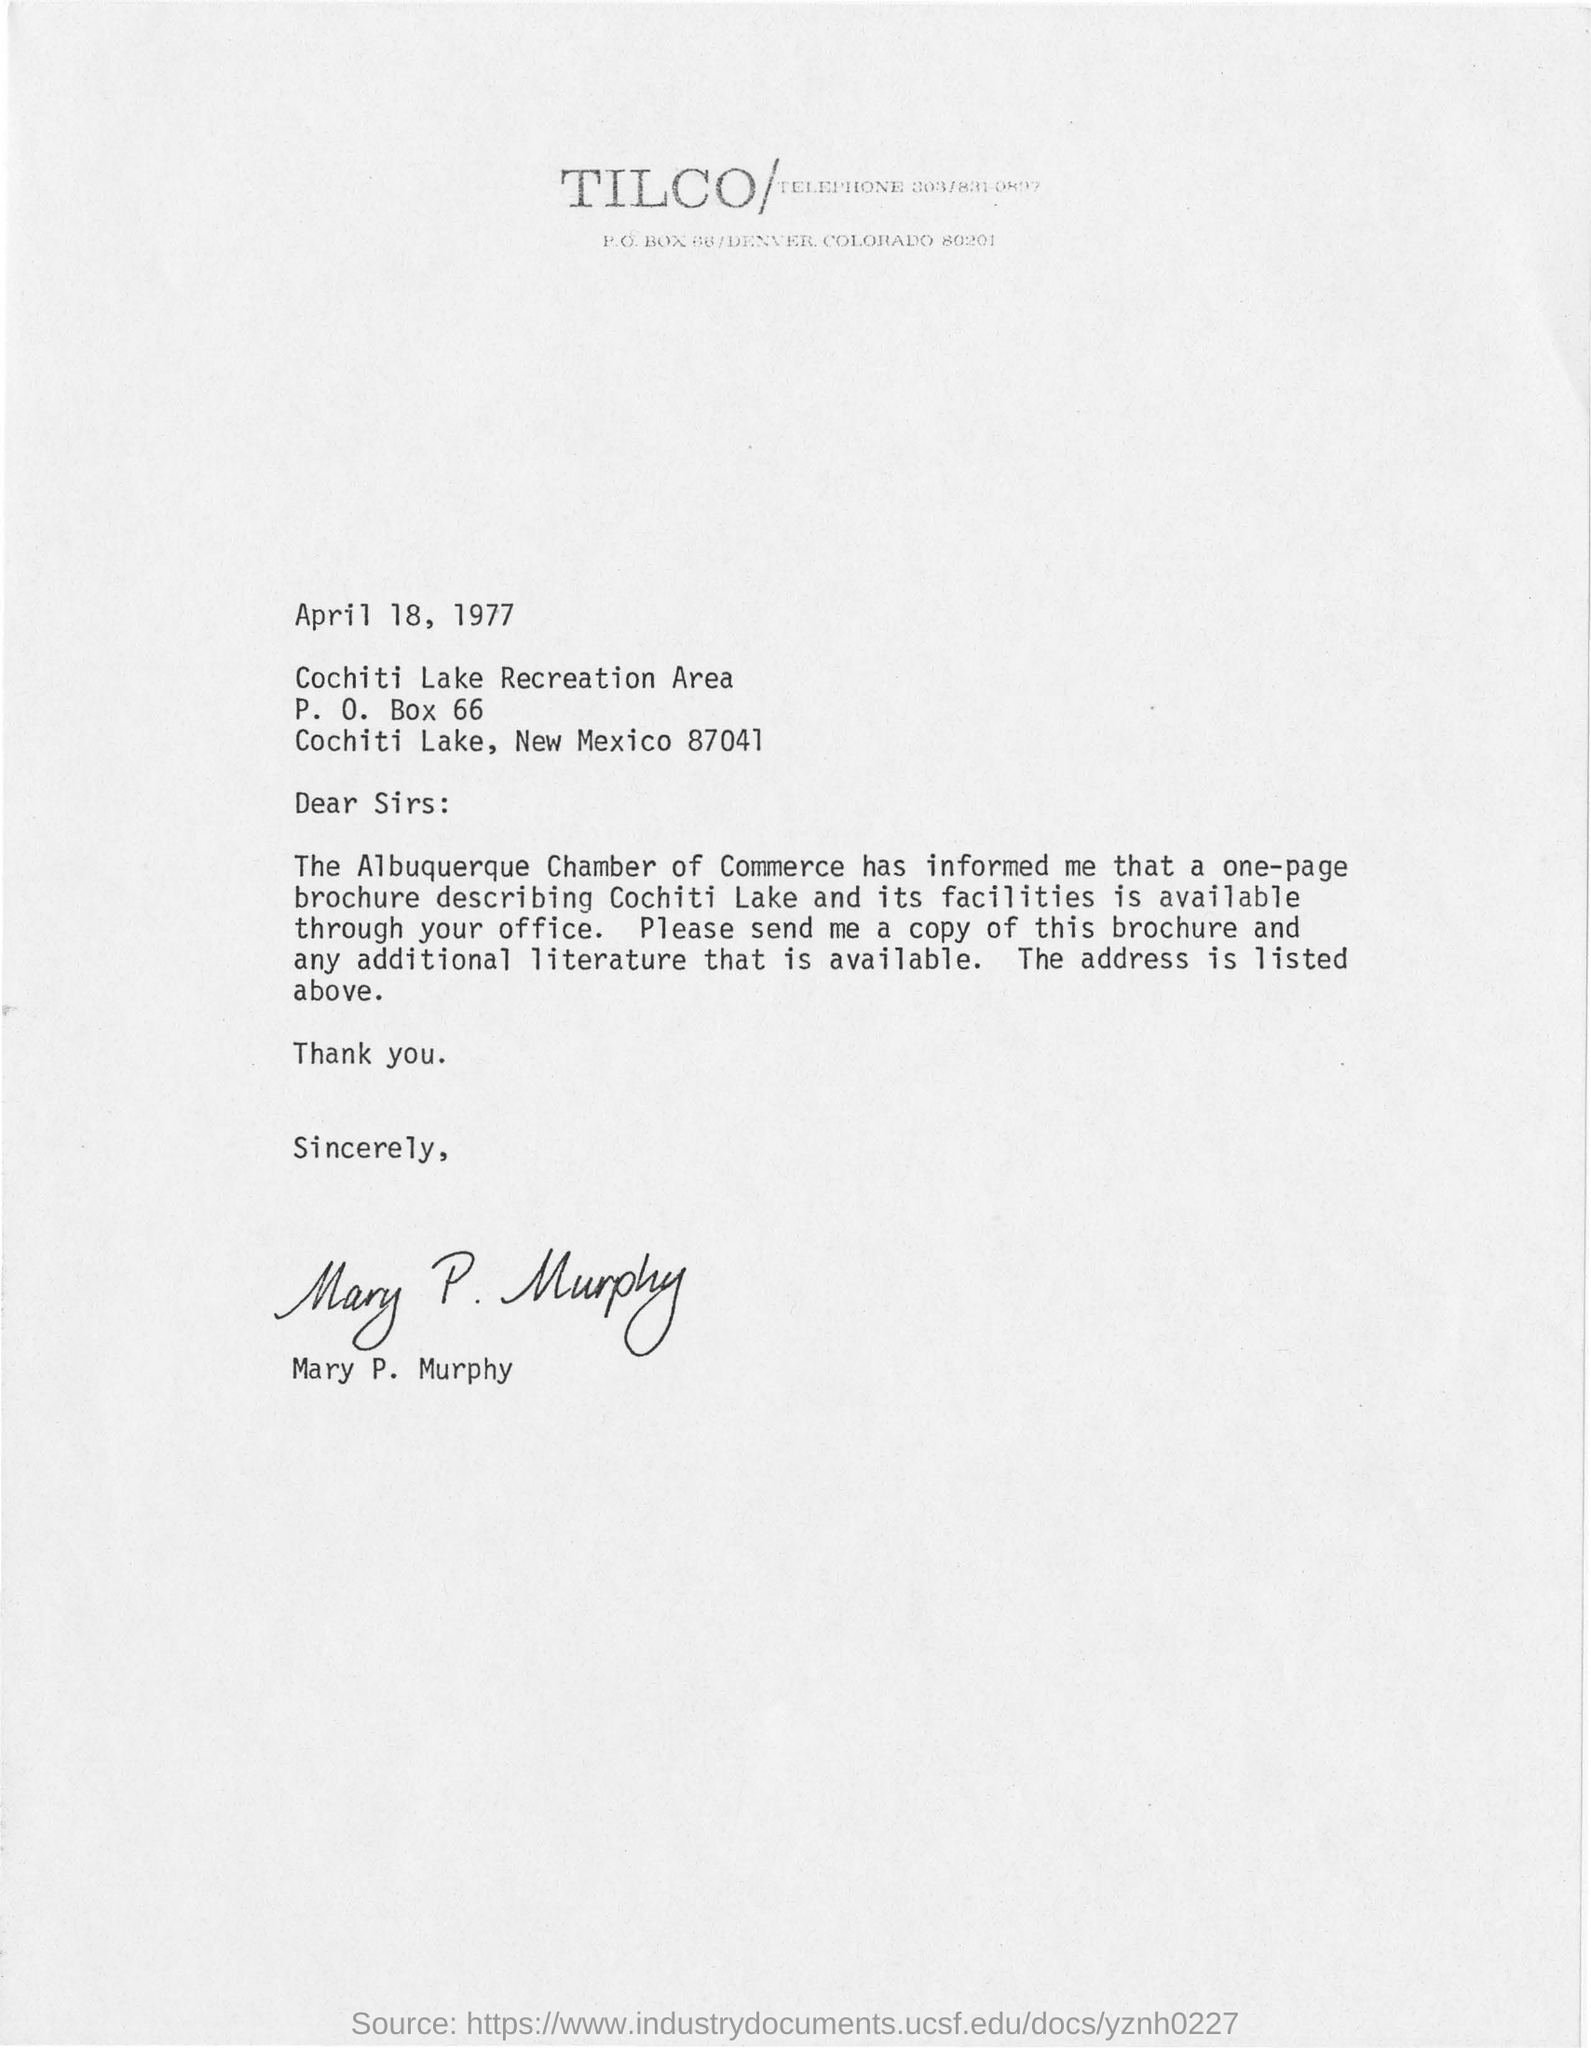List a handful of essential elements in this visual. The writer of this letter is Mary P. Murphy. The letter was written on April 18, 1977. The P.O Box Number in the letter is 66... 